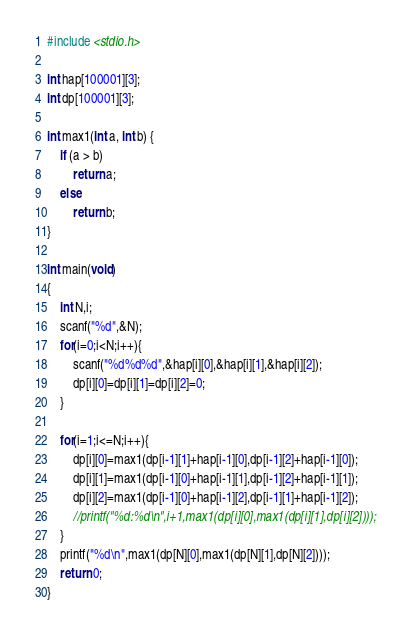Convert code to text. <code><loc_0><loc_0><loc_500><loc_500><_C_>#include <stdio.h>

int hap[100001][3];
int dp[100001][3];

int max1(int a, int b) {
    if (a > b)
        return a;
    else
        return b;
}

int main(void)
{
	int N,i;
	scanf("%d",&N);
	for(i=0;i<N;i++){
		scanf("%d%d%d",&hap[i][0],&hap[i][1],&hap[i][2]);
		dp[i][0]=dp[i][1]=dp[i][2]=0;
	}
	
	for(i=1;i<=N;i++){
		dp[i][0]=max1(dp[i-1][1]+hap[i-1][0],dp[i-1][2]+hap[i-1][0]);
		dp[i][1]=max1(dp[i-1][0]+hap[i-1][1],dp[i-1][2]+hap[i-1][1]);
		dp[i][2]=max1(dp[i-1][0]+hap[i-1][2],dp[i-1][1]+hap[i-1][2]);
		//printf("%d:%d\n",i+1,max1(dp[i][0],max1(dp[i][1],dp[i][2])));
	}
	printf("%d\n",max1(dp[N][0],max1(dp[N][1],dp[N][2])));
	return 0;
}
</code> 